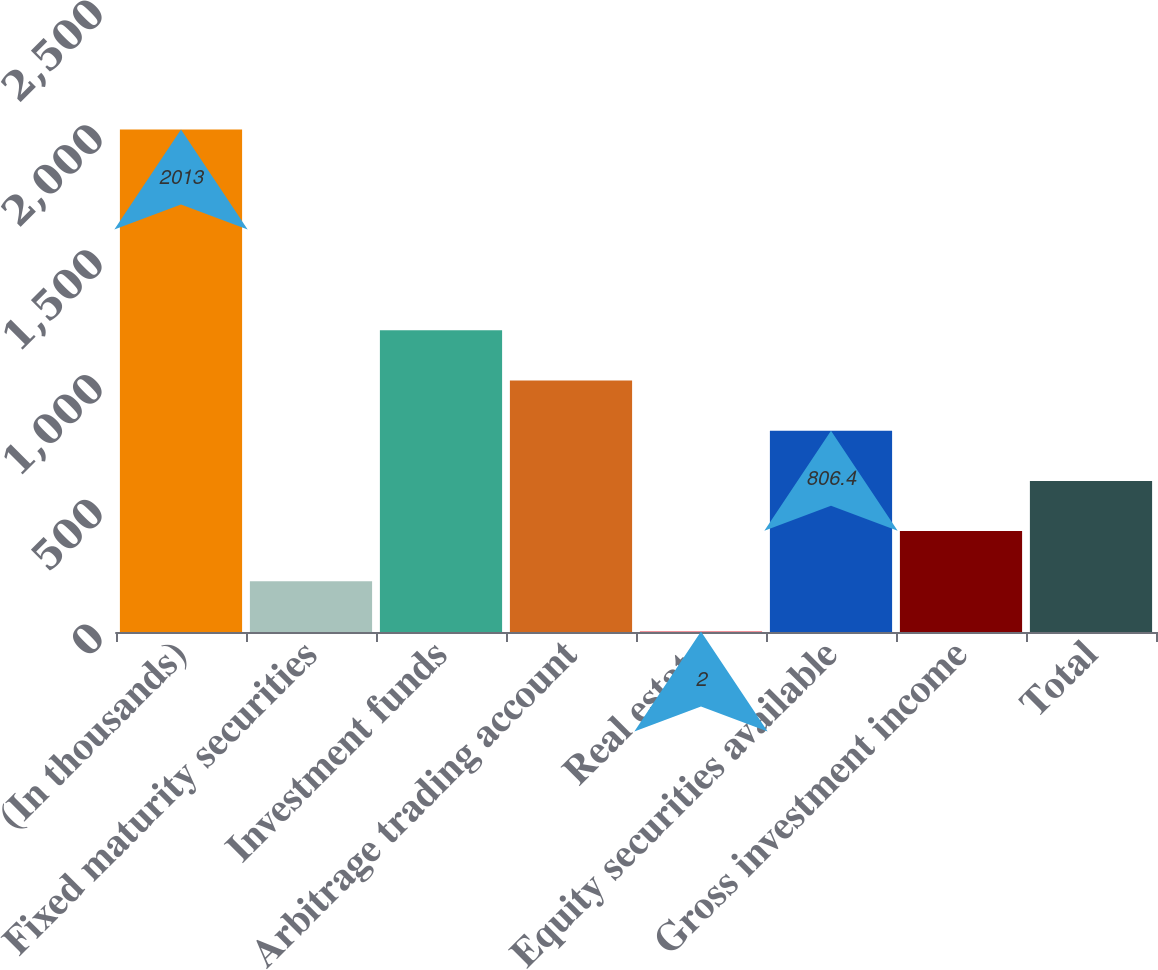Convert chart. <chart><loc_0><loc_0><loc_500><loc_500><bar_chart><fcel>(In thousands)<fcel>Fixed maturity securities<fcel>Investment funds<fcel>Arbitrage trading account<fcel>Real estate<fcel>Equity securities available<fcel>Gross investment income<fcel>Total<nl><fcel>2013<fcel>203.1<fcel>1208.6<fcel>1007.5<fcel>2<fcel>806.4<fcel>404.2<fcel>605.3<nl></chart> 